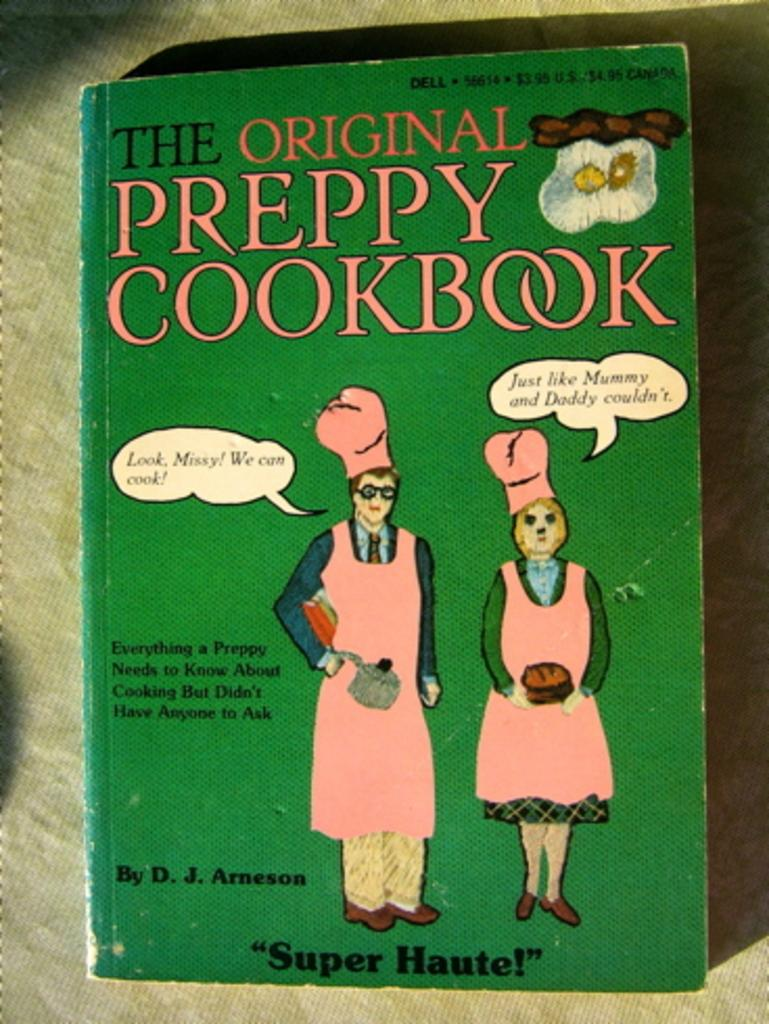Provide a one-sentence caption for the provided image. An old green cookbook called The Original Preppy Cookbook. 